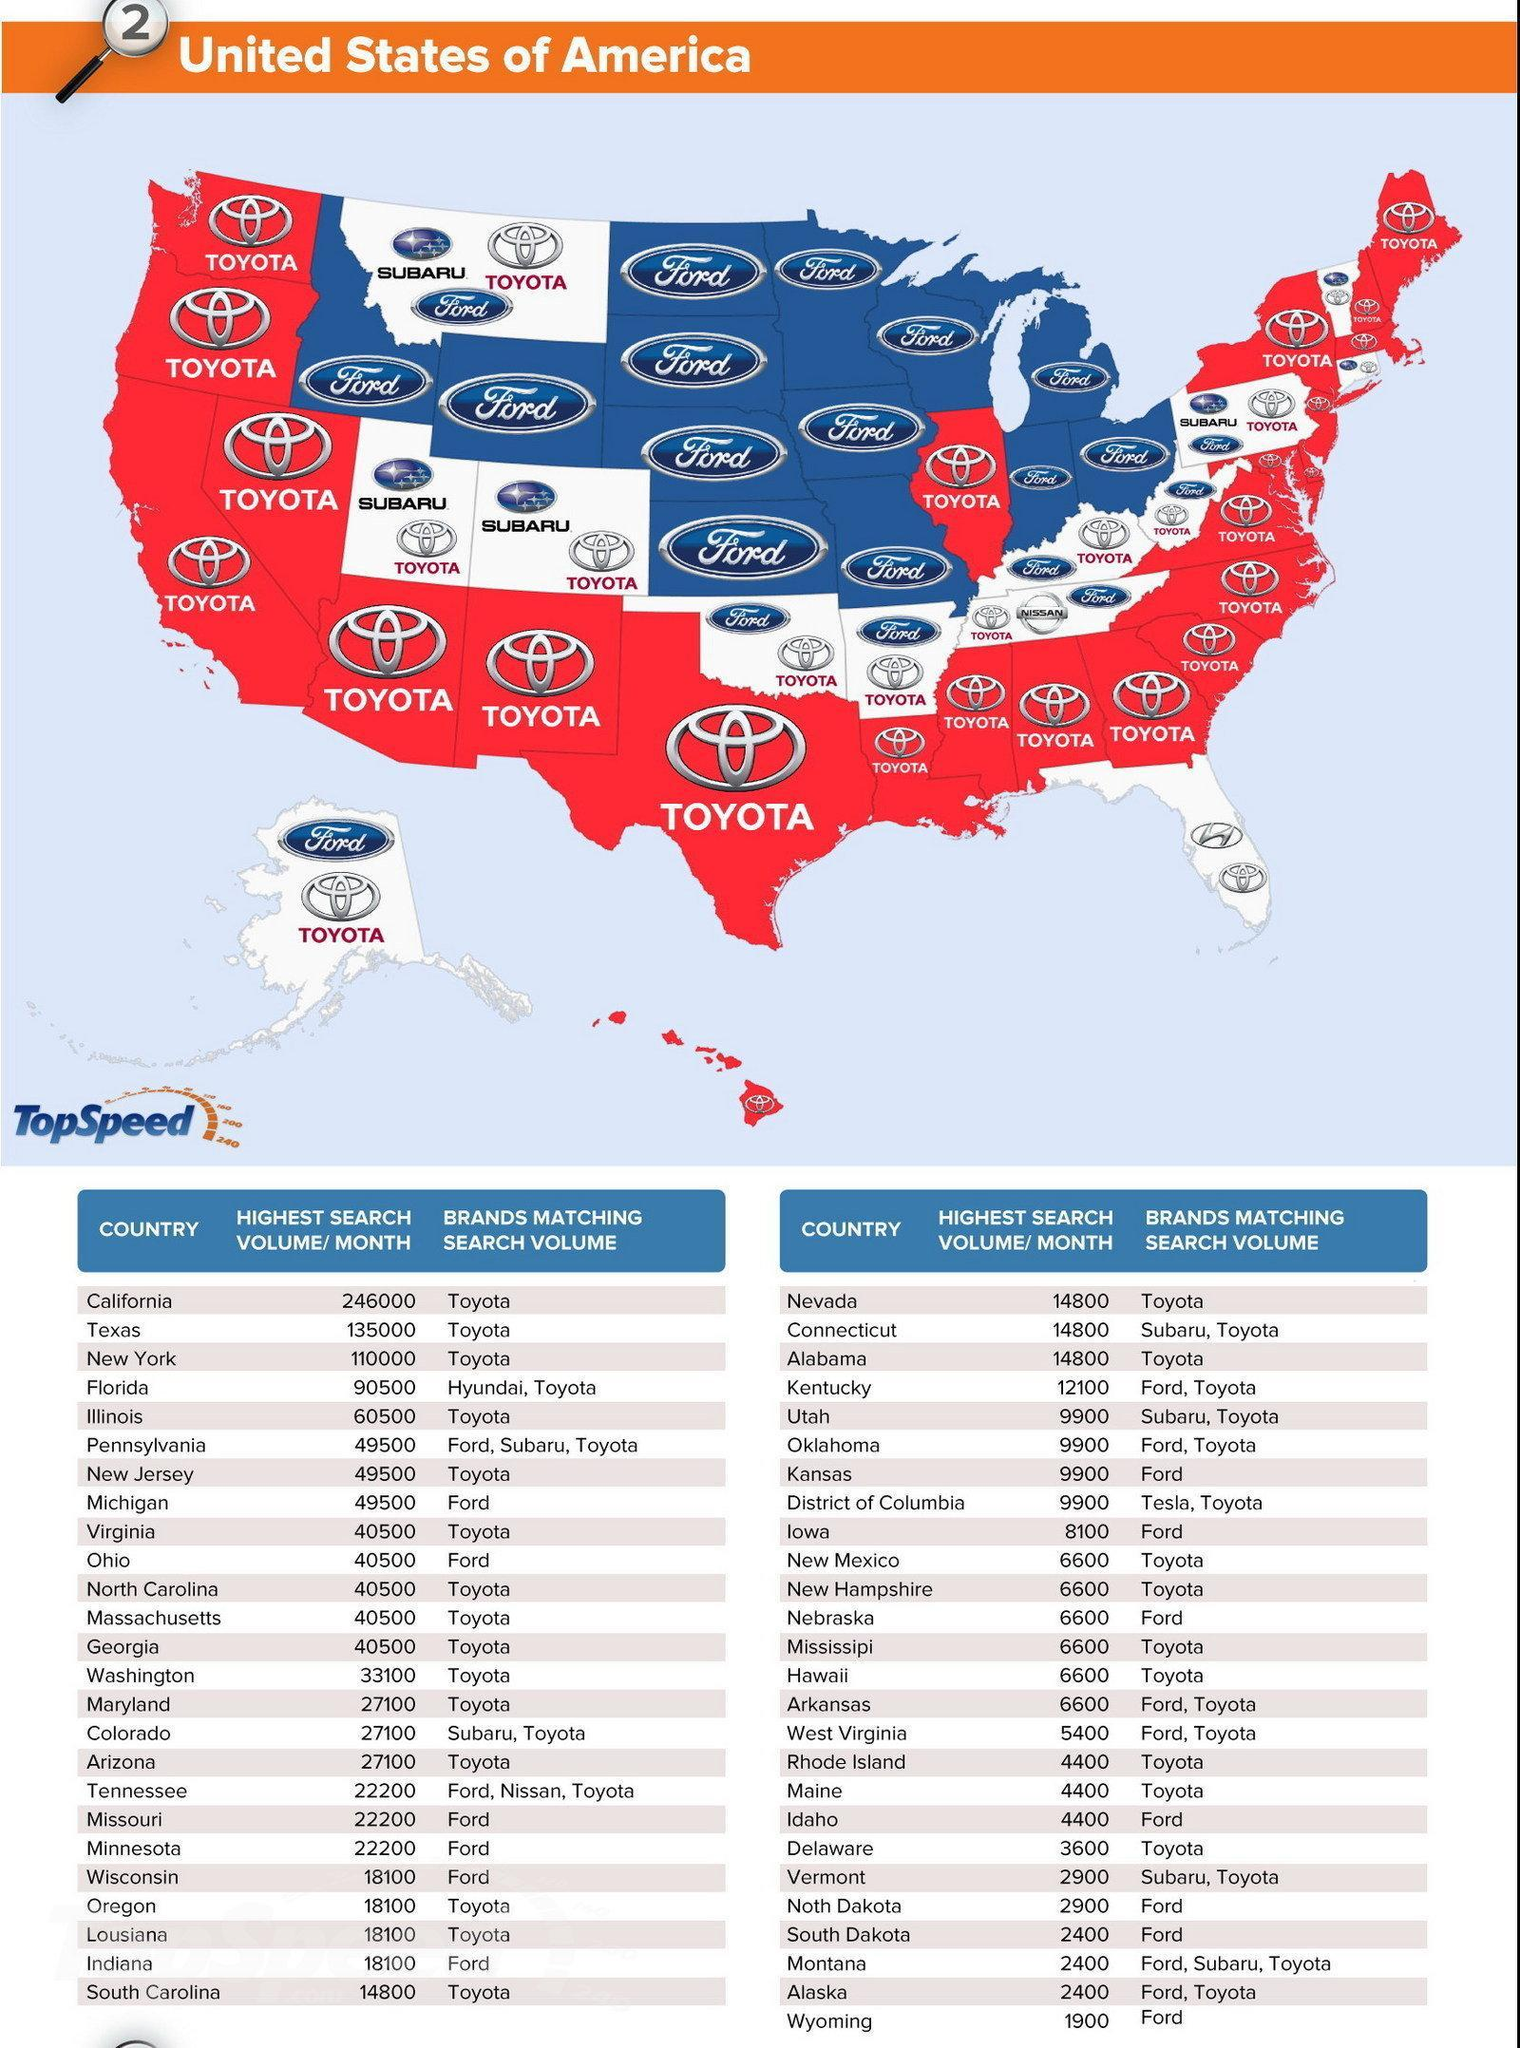How many countries are listed in the table?
Answer the question with a short phrase. 51 From the map, how many states are shared by Subaru and Toyota ? 4 How many states on the map are shared only by Ford and Toyota? 7 What does the highest search volume per month of South Dakota, Montana, and Alaska correspond to? 2400 What is difference in the values of highest search volumes of California and Texas? 111,000 What is highest search volume listed on the second column and second row ? 135000 What is name of the state in second row fourth column of the table? Connecticut 